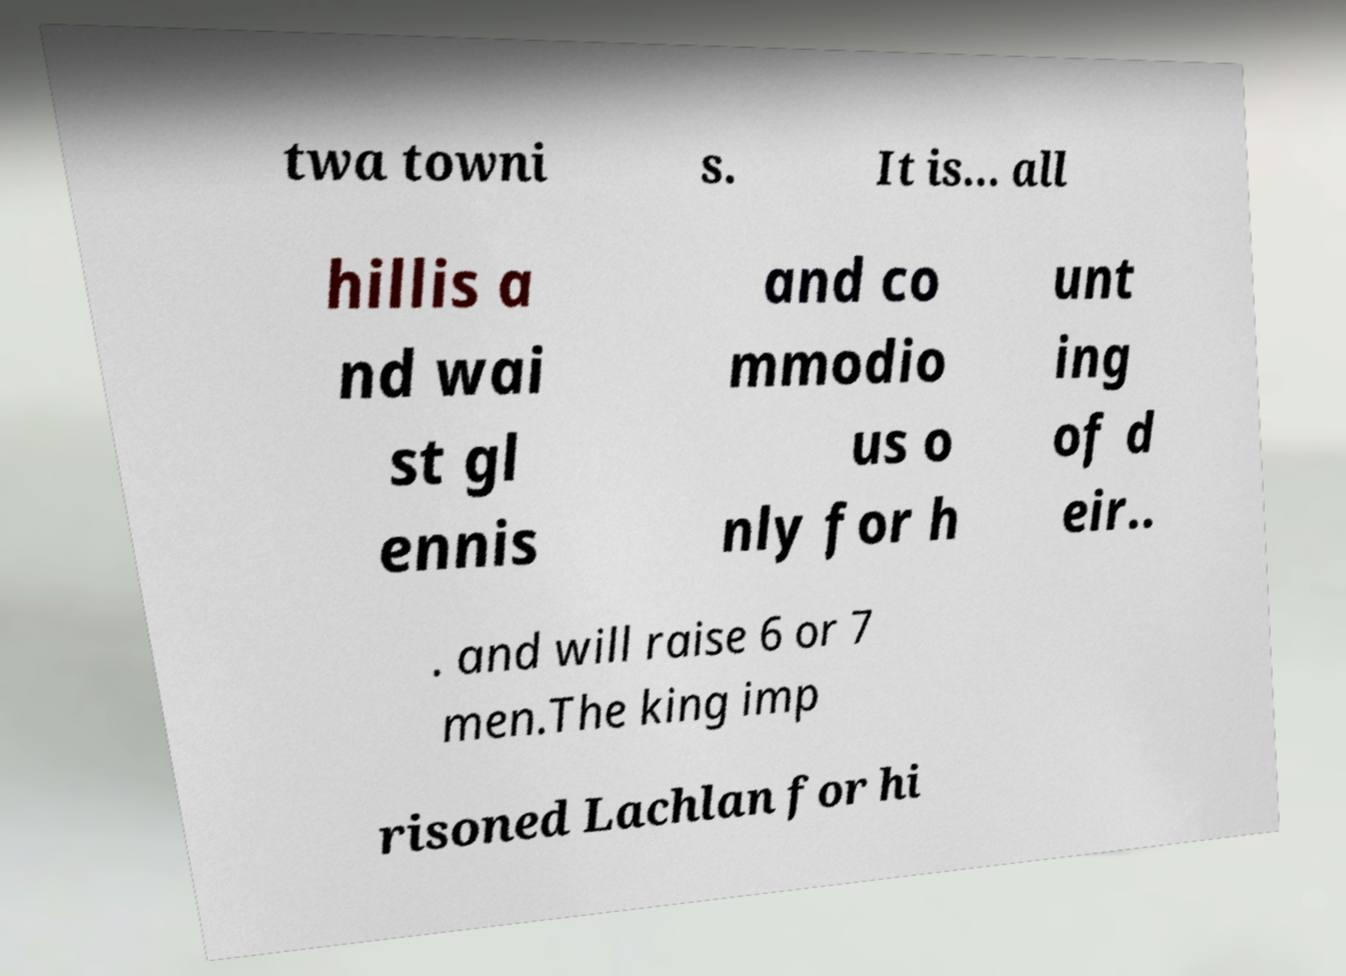Please identify and transcribe the text found in this image. twa towni s. It is... all hillis a nd wai st gl ennis and co mmodio us o nly for h unt ing of d eir.. . and will raise 6 or 7 men.The king imp risoned Lachlan for hi 